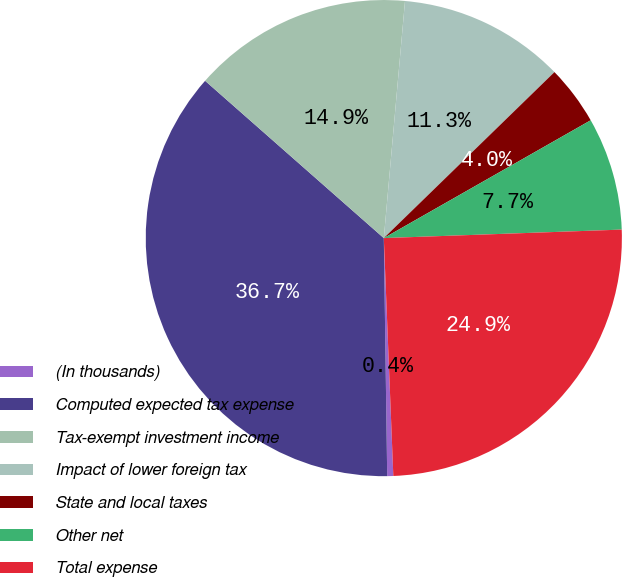<chart> <loc_0><loc_0><loc_500><loc_500><pie_chart><fcel>(In thousands)<fcel>Computed expected tax expense<fcel>Tax-exempt investment income<fcel>Impact of lower foreign tax<fcel>State and local taxes<fcel>Other net<fcel>Total expense<nl><fcel>0.41%<fcel>36.71%<fcel>14.93%<fcel>11.3%<fcel>4.04%<fcel>7.67%<fcel>24.93%<nl></chart> 